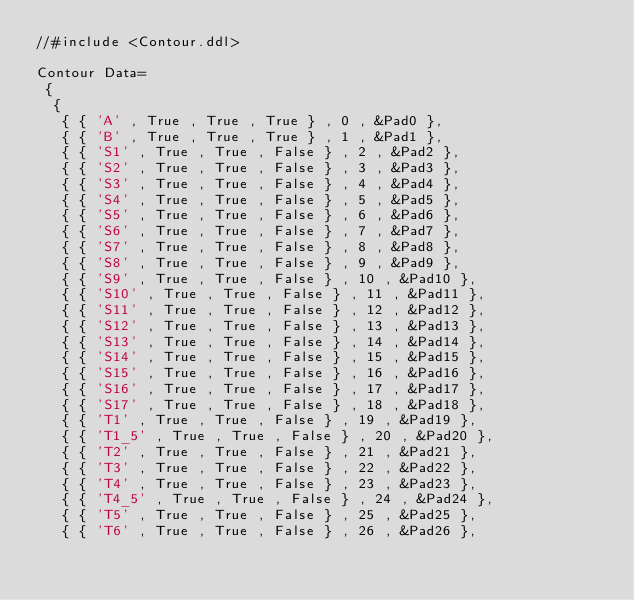<code> <loc_0><loc_0><loc_500><loc_500><_SQL_>//#include <Contour.ddl>

Contour Data=
 {
  {
   { { 'A' , True , True , True } , 0 , &Pad0 },
   { { 'B' , True , True , True } , 1 , &Pad1 },
   { { 'S1' , True , True , False } , 2 , &Pad2 },
   { { 'S2' , True , True , False } , 3 , &Pad3 },
   { { 'S3' , True , True , False } , 4 , &Pad4 },
   { { 'S4' , True , True , False } , 5 , &Pad5 },
   { { 'S5' , True , True , False } , 6 , &Pad6 },
   { { 'S6' , True , True , False } , 7 , &Pad7 },
   { { 'S7' , True , True , False } , 8 , &Pad8 },
   { { 'S8' , True , True , False } , 9 , &Pad9 },
   { { 'S9' , True , True , False } , 10 , &Pad10 },
   { { 'S10' , True , True , False } , 11 , &Pad11 },
   { { 'S11' , True , True , False } , 12 , &Pad12 },
   { { 'S12' , True , True , False } , 13 , &Pad13 },
   { { 'S13' , True , True , False } , 14 , &Pad14 },
   { { 'S14' , True , True , False } , 15 , &Pad15 },
   { { 'S15' , True , True , False } , 16 , &Pad16 },
   { { 'S16' , True , True , False } , 17 , &Pad17 },
   { { 'S17' , True , True , False } , 18 , &Pad18 },
   { { 'T1' , True , True , False } , 19 , &Pad19 },
   { { 'T1_5' , True , True , False } , 20 , &Pad20 },
   { { 'T2' , True , True , False } , 21 , &Pad21 },
   { { 'T3' , True , True , False } , 22 , &Pad22 },
   { { 'T4' , True , True , False } , 23 , &Pad23 },
   { { 'T4_5' , True , True , False } , 24 , &Pad24 },
   { { 'T5' , True , True , False } , 25 , &Pad25 },
   { { 'T6' , True , True , False } , 26 , &Pad26 },</code> 